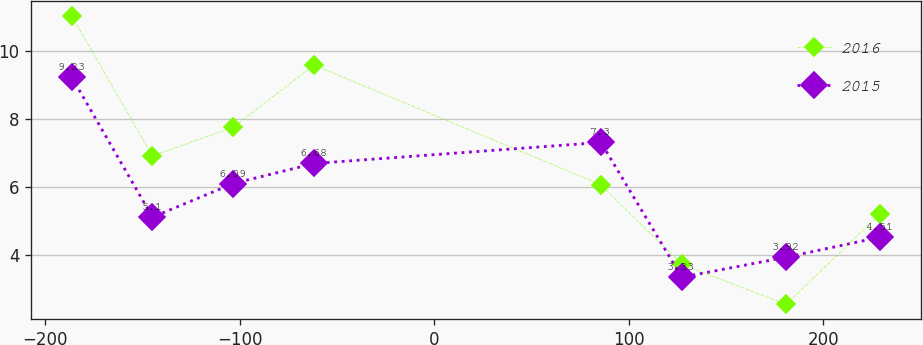Convert chart to OTSL. <chart><loc_0><loc_0><loc_500><loc_500><line_chart><ecel><fcel>2016<fcel>2015<nl><fcel>-186.45<fcel>11.03<fcel>9.23<nl><fcel>-144.89<fcel>6.9<fcel>5.1<nl><fcel>-103.33<fcel>7.75<fcel>6.09<nl><fcel>-61.77<fcel>9.58<fcel>6.68<nl><fcel>85.61<fcel>6.05<fcel>7.3<nl><fcel>127.16<fcel>3.71<fcel>3.33<nl><fcel>180.76<fcel>2.53<fcel>3.92<nl><fcel>229.1<fcel>5.2<fcel>4.51<nl></chart> 